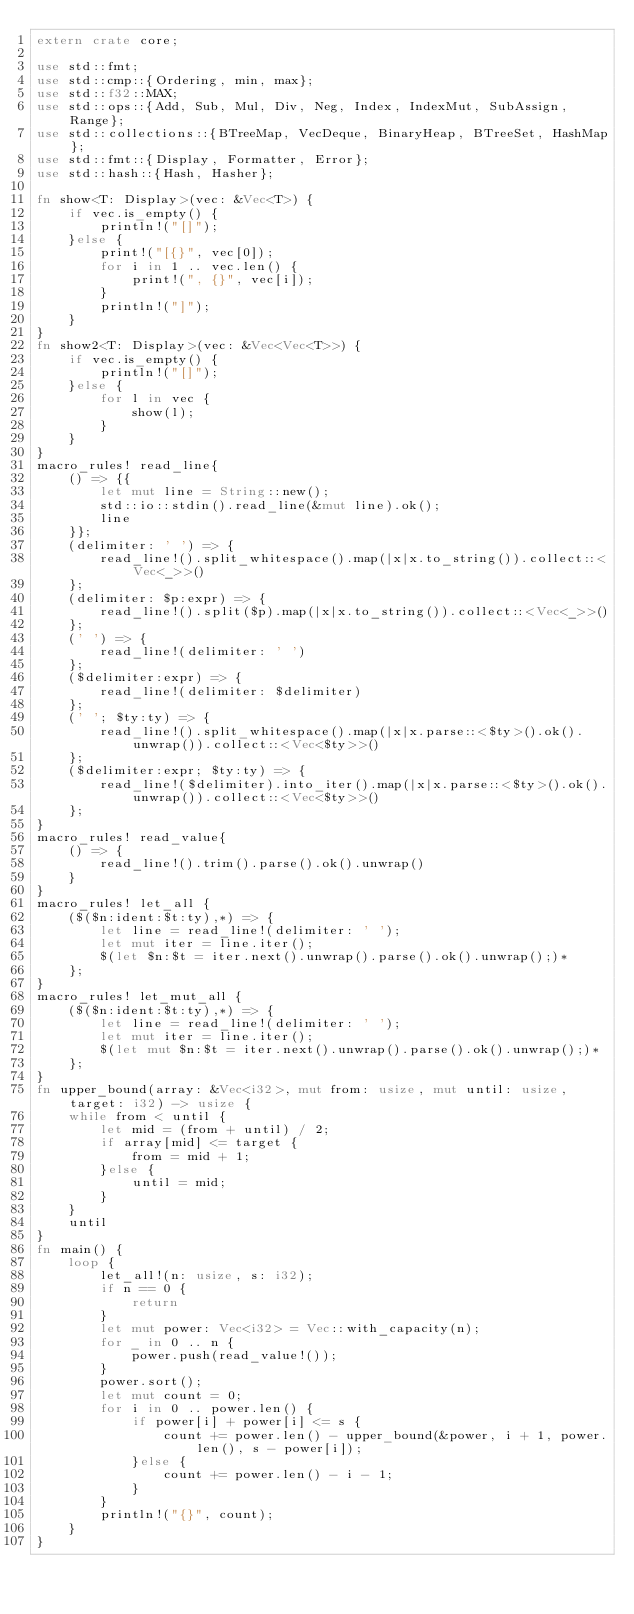Convert code to text. <code><loc_0><loc_0><loc_500><loc_500><_Rust_>extern crate core;

use std::fmt;
use std::cmp::{Ordering, min, max};
use std::f32::MAX;
use std::ops::{Add, Sub, Mul, Div, Neg, Index, IndexMut, SubAssign, Range};
use std::collections::{BTreeMap, VecDeque, BinaryHeap, BTreeSet, HashMap};
use std::fmt::{Display, Formatter, Error};
use std::hash::{Hash, Hasher};

fn show<T: Display>(vec: &Vec<T>) {
    if vec.is_empty() {
        println!("[]");
    }else {
        print!("[{}", vec[0]);
        for i in 1 .. vec.len() {
            print!(", {}", vec[i]);
        }
        println!("]");
    }
}
fn show2<T: Display>(vec: &Vec<Vec<T>>) {
    if vec.is_empty() {
        println!("[]");
    }else {
        for l in vec {
            show(l);
        }
    }
}
macro_rules! read_line{
    () => {{
        let mut line = String::new();
        std::io::stdin().read_line(&mut line).ok();
        line
    }};
    (delimiter: ' ') => {
        read_line!().split_whitespace().map(|x|x.to_string()).collect::<Vec<_>>()
    };
    (delimiter: $p:expr) => {
        read_line!().split($p).map(|x|x.to_string()).collect::<Vec<_>>()
    };
    (' ') => {
        read_line!(delimiter: ' ')
    };
    ($delimiter:expr) => {
        read_line!(delimiter: $delimiter)
    };
    (' '; $ty:ty) => {
        read_line!().split_whitespace().map(|x|x.parse::<$ty>().ok().unwrap()).collect::<Vec<$ty>>()
    };
    ($delimiter:expr; $ty:ty) => {
        read_line!($delimiter).into_iter().map(|x|x.parse::<$ty>().ok().unwrap()).collect::<Vec<$ty>>()
    };
}
macro_rules! read_value{
    () => {
        read_line!().trim().parse().ok().unwrap()
    }
}
macro_rules! let_all {
    ($($n:ident:$t:ty),*) => {
        let line = read_line!(delimiter: ' ');
        let mut iter = line.iter();
        $(let $n:$t = iter.next().unwrap().parse().ok().unwrap();)*
    };
}
macro_rules! let_mut_all {
    ($($n:ident:$t:ty),*) => {
        let line = read_line!(delimiter: ' ');
        let mut iter = line.iter();
        $(let mut $n:$t = iter.next().unwrap().parse().ok().unwrap();)*
    };
}
fn upper_bound(array: &Vec<i32>, mut from: usize, mut until: usize, target: i32) -> usize {
    while from < until {
        let mid = (from + until) / 2;
        if array[mid] <= target {
            from = mid + 1;
        }else {
            until = mid;
        }
    }
    until
}
fn main() {
    loop {
        let_all!(n: usize, s: i32);
        if n == 0 {
            return
        }
        let mut power: Vec<i32> = Vec::with_capacity(n);
        for _ in 0 .. n {
            power.push(read_value!());
        }
        power.sort();
        let mut count = 0;
        for i in 0 .. power.len() {
            if power[i] + power[i] <= s {
                count += power.len() - upper_bound(&power, i + 1, power.len(), s - power[i]);
            }else {
                count += power.len() - i - 1;
            }
        }
        println!("{}", count);
    }
}
</code> 